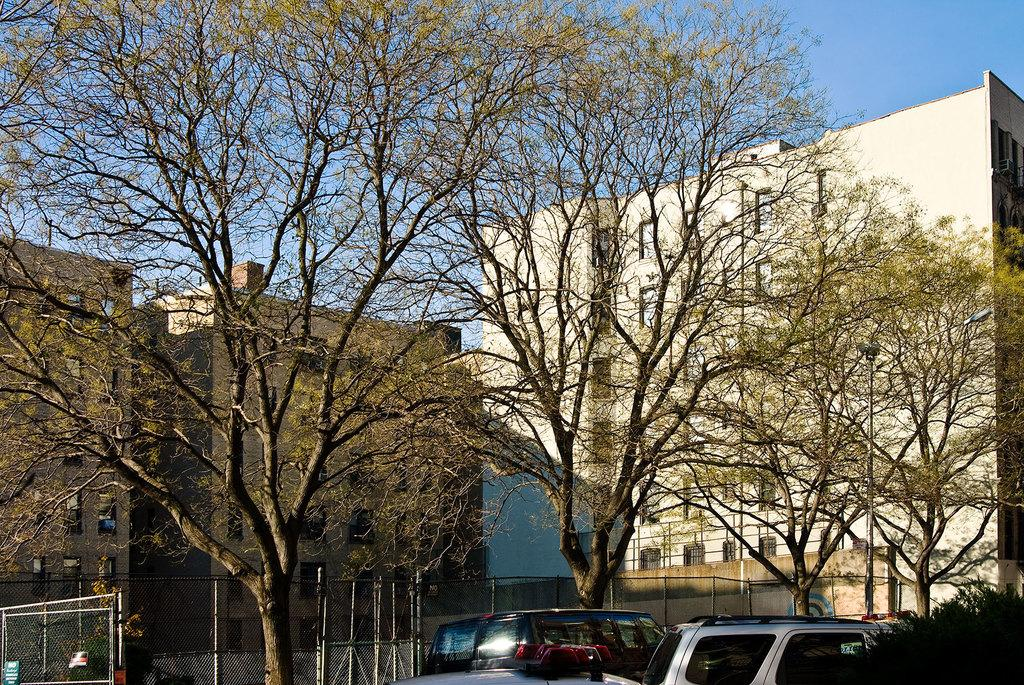What can be seen on the right side of the image? There are vehicles on the right side of the image. What is the surrounding environment like for the vehicles? There are many tall trees around the vehicles. What structures are visible behind the trees? There are three buildings visible behind the trees. How many sheep can be seen grazing near the vehicles in the image? There are no sheep present in the image. What type of footwear is the beginner wearing while standing near the vehicles? There is no person or footwear visible in the image. 